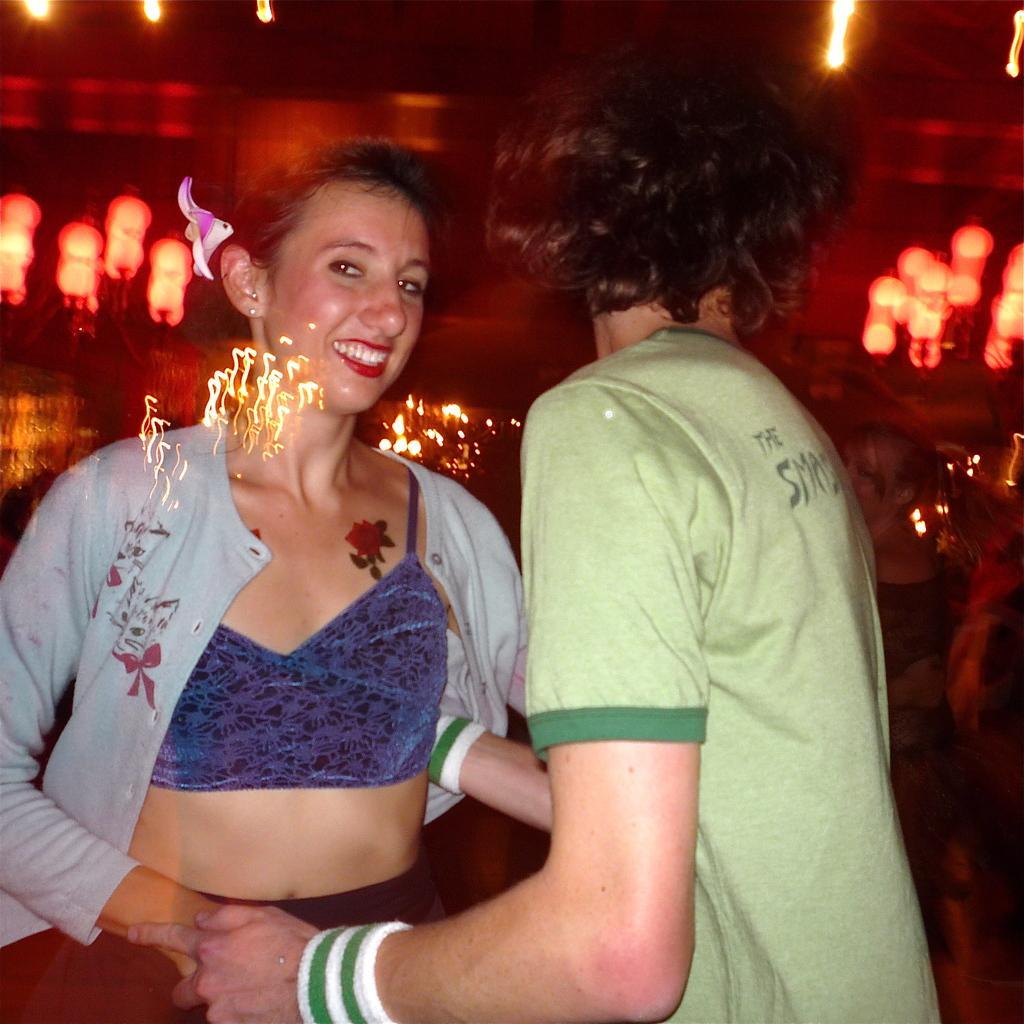How would you summarize this image in a sentence or two? In this image there is a couple dancing. In the background there are few lights. 